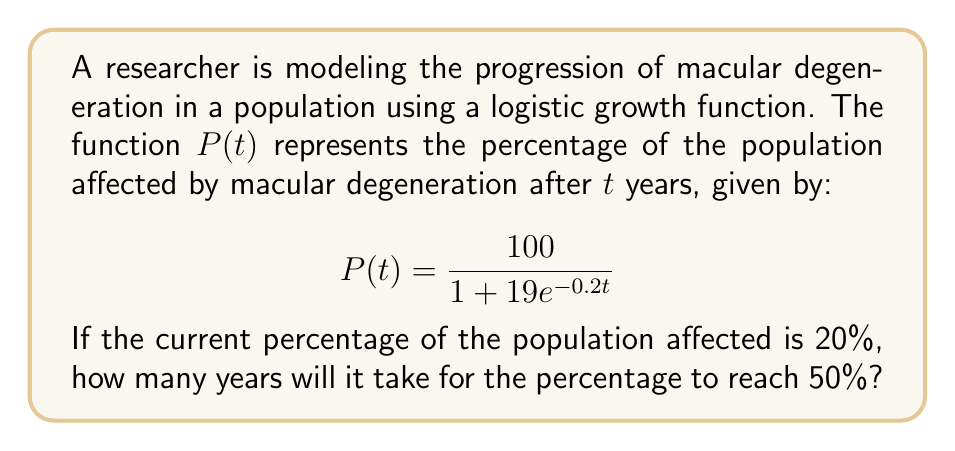Give your solution to this math problem. To solve this problem, we need to use the given logistic growth function and determine the time $t$ when $P(t) = 50\%$. Let's approach this step-by-step:

1) We start with the logistic growth function:
   $$P(t) = \frac{100}{1 + 19e^{-0.2t}}$$

2) We want to find $t$ when $P(t) = 50$, so we set up the equation:
   $$50 = \frac{100}{1 + 19e^{-0.2t}}$$

3) Multiply both sides by $(1 + 19e^{-0.2t})$:
   $$50(1 + 19e^{-0.2t}) = 100$$

4) Distribute on the left side:
   $$50 + 950e^{-0.2t} = 100$$

5) Subtract 50 from both sides:
   $$950e^{-0.2t} = 50$$

6) Divide both sides by 950:
   $$e^{-0.2t} = \frac{1}{19}$$

7) Take the natural log of both sides:
   $$-0.2t = \ln(\frac{1}{19})$$

8) Divide both sides by -0.2:
   $$t = -\frac{\ln(\frac{1}{19})}{0.2}$$

9) Simplify:
   $$t = \frac{\ln(19)}{0.2} \approx 14.73$$

Therefore, it will take approximately 14.73 years for the percentage of the population affected by macular degeneration to reach 50%.
Answer: $t \approx 14.73$ years 